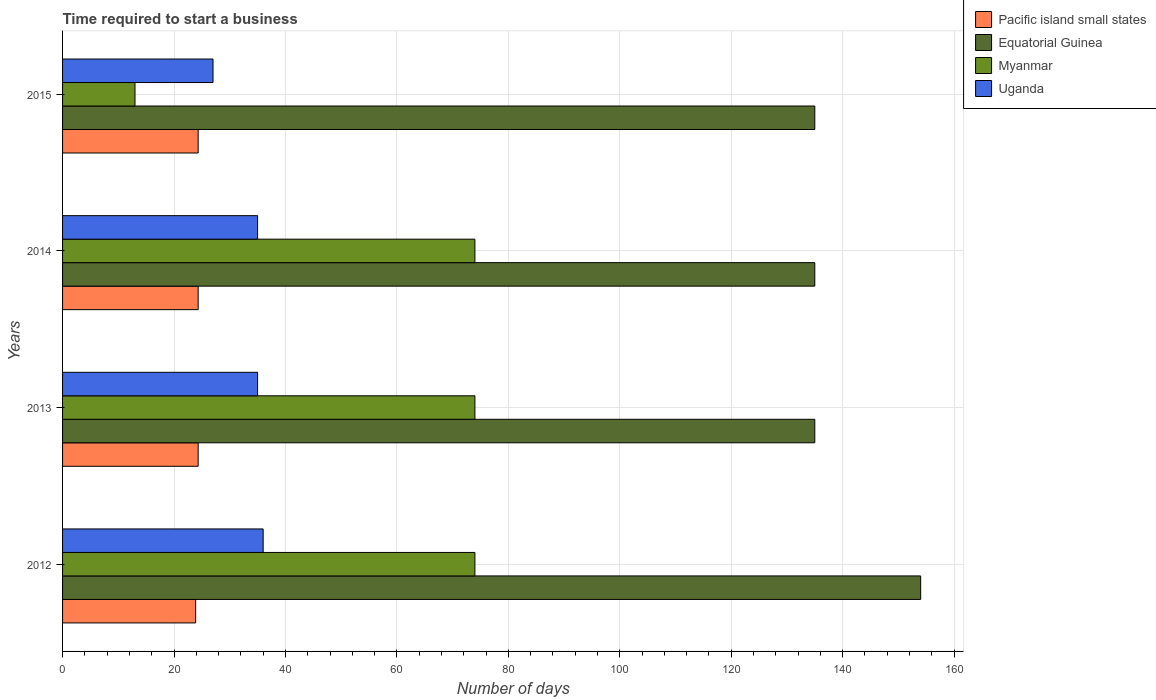In how many cases, is the number of bars for a given year not equal to the number of legend labels?
Your response must be concise. 0. Across all years, what is the maximum number of days required to start a business in Myanmar?
Your response must be concise. 74. Across all years, what is the minimum number of days required to start a business in Uganda?
Your answer should be very brief. 27. In which year was the number of days required to start a business in Equatorial Guinea minimum?
Ensure brevity in your answer.  2013. What is the total number of days required to start a business in Uganda in the graph?
Your answer should be very brief. 133. What is the difference between the number of days required to start a business in Myanmar in 2013 and the number of days required to start a business in Uganda in 2012?
Offer a terse response. 38. What is the average number of days required to start a business in Uganda per year?
Provide a short and direct response. 33.25. In the year 2015, what is the difference between the number of days required to start a business in Myanmar and number of days required to start a business in Pacific island small states?
Ensure brevity in your answer.  -11.33. In how many years, is the number of days required to start a business in Equatorial Guinea greater than 92 days?
Ensure brevity in your answer.  4. What is the ratio of the number of days required to start a business in Uganda in 2012 to that in 2015?
Your answer should be very brief. 1.33. Is the number of days required to start a business in Myanmar in 2013 less than that in 2014?
Your answer should be compact. No. What is the difference between the highest and the second highest number of days required to start a business in Equatorial Guinea?
Offer a very short reply. 19. What is the difference between the highest and the lowest number of days required to start a business in Myanmar?
Keep it short and to the point. 61. What does the 2nd bar from the top in 2013 represents?
Ensure brevity in your answer.  Myanmar. What does the 1st bar from the bottom in 2012 represents?
Your response must be concise. Pacific island small states. Is it the case that in every year, the sum of the number of days required to start a business in Myanmar and number of days required to start a business in Uganda is greater than the number of days required to start a business in Pacific island small states?
Keep it short and to the point. Yes. Are the values on the major ticks of X-axis written in scientific E-notation?
Keep it short and to the point. No. Where does the legend appear in the graph?
Provide a short and direct response. Top right. What is the title of the graph?
Your response must be concise. Time required to start a business. Does "Suriname" appear as one of the legend labels in the graph?
Keep it short and to the point. No. What is the label or title of the X-axis?
Keep it short and to the point. Number of days. What is the label or title of the Y-axis?
Give a very brief answer. Years. What is the Number of days in Pacific island small states in 2012?
Give a very brief answer. 23.89. What is the Number of days in Equatorial Guinea in 2012?
Make the answer very short. 154. What is the Number of days of Myanmar in 2012?
Ensure brevity in your answer.  74. What is the Number of days in Uganda in 2012?
Your response must be concise. 36. What is the Number of days in Pacific island small states in 2013?
Your response must be concise. 24.33. What is the Number of days in Equatorial Guinea in 2013?
Your answer should be compact. 135. What is the Number of days of Uganda in 2013?
Your answer should be very brief. 35. What is the Number of days of Pacific island small states in 2014?
Make the answer very short. 24.33. What is the Number of days of Equatorial Guinea in 2014?
Offer a very short reply. 135. What is the Number of days in Uganda in 2014?
Provide a succinct answer. 35. What is the Number of days in Pacific island small states in 2015?
Your answer should be very brief. 24.33. What is the Number of days of Equatorial Guinea in 2015?
Offer a terse response. 135. What is the Number of days of Myanmar in 2015?
Provide a succinct answer. 13. What is the Number of days of Uganda in 2015?
Make the answer very short. 27. Across all years, what is the maximum Number of days of Pacific island small states?
Your answer should be compact. 24.33. Across all years, what is the maximum Number of days of Equatorial Guinea?
Your answer should be very brief. 154. Across all years, what is the minimum Number of days of Pacific island small states?
Make the answer very short. 23.89. Across all years, what is the minimum Number of days of Equatorial Guinea?
Your response must be concise. 135. Across all years, what is the minimum Number of days of Myanmar?
Offer a terse response. 13. What is the total Number of days in Pacific island small states in the graph?
Your answer should be very brief. 96.89. What is the total Number of days in Equatorial Guinea in the graph?
Your response must be concise. 559. What is the total Number of days in Myanmar in the graph?
Your answer should be compact. 235. What is the total Number of days of Uganda in the graph?
Your response must be concise. 133. What is the difference between the Number of days of Pacific island small states in 2012 and that in 2013?
Your answer should be very brief. -0.44. What is the difference between the Number of days of Myanmar in 2012 and that in 2013?
Your response must be concise. 0. What is the difference between the Number of days of Pacific island small states in 2012 and that in 2014?
Offer a terse response. -0.44. What is the difference between the Number of days of Equatorial Guinea in 2012 and that in 2014?
Your answer should be very brief. 19. What is the difference between the Number of days of Pacific island small states in 2012 and that in 2015?
Offer a very short reply. -0.44. What is the difference between the Number of days in Equatorial Guinea in 2012 and that in 2015?
Keep it short and to the point. 19. What is the difference between the Number of days of Myanmar in 2012 and that in 2015?
Provide a succinct answer. 61. What is the difference between the Number of days of Pacific island small states in 2013 and that in 2014?
Give a very brief answer. 0. What is the difference between the Number of days of Myanmar in 2013 and that in 2014?
Keep it short and to the point. 0. What is the difference between the Number of days in Uganda in 2013 and that in 2014?
Offer a terse response. 0. What is the difference between the Number of days of Pacific island small states in 2013 and that in 2015?
Offer a very short reply. 0. What is the difference between the Number of days in Equatorial Guinea in 2013 and that in 2015?
Give a very brief answer. 0. What is the difference between the Number of days of Myanmar in 2013 and that in 2015?
Your answer should be compact. 61. What is the difference between the Number of days in Pacific island small states in 2014 and that in 2015?
Give a very brief answer. 0. What is the difference between the Number of days in Pacific island small states in 2012 and the Number of days in Equatorial Guinea in 2013?
Your answer should be compact. -111.11. What is the difference between the Number of days in Pacific island small states in 2012 and the Number of days in Myanmar in 2013?
Your response must be concise. -50.11. What is the difference between the Number of days of Pacific island small states in 2012 and the Number of days of Uganda in 2013?
Your answer should be compact. -11.11. What is the difference between the Number of days in Equatorial Guinea in 2012 and the Number of days in Uganda in 2013?
Provide a short and direct response. 119. What is the difference between the Number of days of Myanmar in 2012 and the Number of days of Uganda in 2013?
Make the answer very short. 39. What is the difference between the Number of days in Pacific island small states in 2012 and the Number of days in Equatorial Guinea in 2014?
Ensure brevity in your answer.  -111.11. What is the difference between the Number of days in Pacific island small states in 2012 and the Number of days in Myanmar in 2014?
Offer a terse response. -50.11. What is the difference between the Number of days in Pacific island small states in 2012 and the Number of days in Uganda in 2014?
Keep it short and to the point. -11.11. What is the difference between the Number of days in Equatorial Guinea in 2012 and the Number of days in Myanmar in 2014?
Your answer should be compact. 80. What is the difference between the Number of days of Equatorial Guinea in 2012 and the Number of days of Uganda in 2014?
Your answer should be very brief. 119. What is the difference between the Number of days in Myanmar in 2012 and the Number of days in Uganda in 2014?
Offer a very short reply. 39. What is the difference between the Number of days of Pacific island small states in 2012 and the Number of days of Equatorial Guinea in 2015?
Give a very brief answer. -111.11. What is the difference between the Number of days of Pacific island small states in 2012 and the Number of days of Myanmar in 2015?
Your response must be concise. 10.89. What is the difference between the Number of days of Pacific island small states in 2012 and the Number of days of Uganda in 2015?
Keep it short and to the point. -3.11. What is the difference between the Number of days in Equatorial Guinea in 2012 and the Number of days in Myanmar in 2015?
Offer a terse response. 141. What is the difference between the Number of days in Equatorial Guinea in 2012 and the Number of days in Uganda in 2015?
Keep it short and to the point. 127. What is the difference between the Number of days in Pacific island small states in 2013 and the Number of days in Equatorial Guinea in 2014?
Offer a very short reply. -110.67. What is the difference between the Number of days in Pacific island small states in 2013 and the Number of days in Myanmar in 2014?
Offer a very short reply. -49.67. What is the difference between the Number of days of Pacific island small states in 2013 and the Number of days of Uganda in 2014?
Offer a very short reply. -10.67. What is the difference between the Number of days of Equatorial Guinea in 2013 and the Number of days of Myanmar in 2014?
Your answer should be compact. 61. What is the difference between the Number of days of Myanmar in 2013 and the Number of days of Uganda in 2014?
Provide a succinct answer. 39. What is the difference between the Number of days of Pacific island small states in 2013 and the Number of days of Equatorial Guinea in 2015?
Keep it short and to the point. -110.67. What is the difference between the Number of days in Pacific island small states in 2013 and the Number of days in Myanmar in 2015?
Your answer should be very brief. 11.33. What is the difference between the Number of days of Pacific island small states in 2013 and the Number of days of Uganda in 2015?
Offer a very short reply. -2.67. What is the difference between the Number of days in Equatorial Guinea in 2013 and the Number of days in Myanmar in 2015?
Offer a very short reply. 122. What is the difference between the Number of days of Equatorial Guinea in 2013 and the Number of days of Uganda in 2015?
Offer a terse response. 108. What is the difference between the Number of days in Pacific island small states in 2014 and the Number of days in Equatorial Guinea in 2015?
Your answer should be very brief. -110.67. What is the difference between the Number of days in Pacific island small states in 2014 and the Number of days in Myanmar in 2015?
Give a very brief answer. 11.33. What is the difference between the Number of days in Pacific island small states in 2014 and the Number of days in Uganda in 2015?
Provide a succinct answer. -2.67. What is the difference between the Number of days in Equatorial Guinea in 2014 and the Number of days in Myanmar in 2015?
Ensure brevity in your answer.  122. What is the difference between the Number of days of Equatorial Guinea in 2014 and the Number of days of Uganda in 2015?
Give a very brief answer. 108. What is the difference between the Number of days in Myanmar in 2014 and the Number of days in Uganda in 2015?
Provide a succinct answer. 47. What is the average Number of days of Pacific island small states per year?
Your response must be concise. 24.22. What is the average Number of days in Equatorial Guinea per year?
Ensure brevity in your answer.  139.75. What is the average Number of days of Myanmar per year?
Keep it short and to the point. 58.75. What is the average Number of days of Uganda per year?
Give a very brief answer. 33.25. In the year 2012, what is the difference between the Number of days of Pacific island small states and Number of days of Equatorial Guinea?
Keep it short and to the point. -130.11. In the year 2012, what is the difference between the Number of days in Pacific island small states and Number of days in Myanmar?
Keep it short and to the point. -50.11. In the year 2012, what is the difference between the Number of days in Pacific island small states and Number of days in Uganda?
Provide a succinct answer. -12.11. In the year 2012, what is the difference between the Number of days in Equatorial Guinea and Number of days in Myanmar?
Offer a terse response. 80. In the year 2012, what is the difference between the Number of days of Equatorial Guinea and Number of days of Uganda?
Your answer should be compact. 118. In the year 2012, what is the difference between the Number of days in Myanmar and Number of days in Uganda?
Your response must be concise. 38. In the year 2013, what is the difference between the Number of days of Pacific island small states and Number of days of Equatorial Guinea?
Offer a terse response. -110.67. In the year 2013, what is the difference between the Number of days in Pacific island small states and Number of days in Myanmar?
Your answer should be compact. -49.67. In the year 2013, what is the difference between the Number of days of Pacific island small states and Number of days of Uganda?
Give a very brief answer. -10.67. In the year 2014, what is the difference between the Number of days in Pacific island small states and Number of days in Equatorial Guinea?
Offer a terse response. -110.67. In the year 2014, what is the difference between the Number of days of Pacific island small states and Number of days of Myanmar?
Make the answer very short. -49.67. In the year 2014, what is the difference between the Number of days of Pacific island small states and Number of days of Uganda?
Your answer should be compact. -10.67. In the year 2014, what is the difference between the Number of days of Equatorial Guinea and Number of days of Uganda?
Provide a short and direct response. 100. In the year 2015, what is the difference between the Number of days in Pacific island small states and Number of days in Equatorial Guinea?
Offer a very short reply. -110.67. In the year 2015, what is the difference between the Number of days of Pacific island small states and Number of days of Myanmar?
Provide a short and direct response. 11.33. In the year 2015, what is the difference between the Number of days of Pacific island small states and Number of days of Uganda?
Offer a very short reply. -2.67. In the year 2015, what is the difference between the Number of days in Equatorial Guinea and Number of days in Myanmar?
Your answer should be compact. 122. In the year 2015, what is the difference between the Number of days in Equatorial Guinea and Number of days in Uganda?
Your answer should be compact. 108. What is the ratio of the Number of days of Pacific island small states in 2012 to that in 2013?
Offer a terse response. 0.98. What is the ratio of the Number of days in Equatorial Guinea in 2012 to that in 2013?
Give a very brief answer. 1.14. What is the ratio of the Number of days of Uganda in 2012 to that in 2013?
Ensure brevity in your answer.  1.03. What is the ratio of the Number of days in Pacific island small states in 2012 to that in 2014?
Provide a succinct answer. 0.98. What is the ratio of the Number of days in Equatorial Guinea in 2012 to that in 2014?
Make the answer very short. 1.14. What is the ratio of the Number of days of Myanmar in 2012 to that in 2014?
Your answer should be compact. 1. What is the ratio of the Number of days of Uganda in 2012 to that in 2014?
Give a very brief answer. 1.03. What is the ratio of the Number of days of Pacific island small states in 2012 to that in 2015?
Your answer should be very brief. 0.98. What is the ratio of the Number of days in Equatorial Guinea in 2012 to that in 2015?
Your answer should be very brief. 1.14. What is the ratio of the Number of days of Myanmar in 2012 to that in 2015?
Your answer should be very brief. 5.69. What is the ratio of the Number of days in Equatorial Guinea in 2013 to that in 2014?
Provide a short and direct response. 1. What is the ratio of the Number of days of Uganda in 2013 to that in 2014?
Provide a short and direct response. 1. What is the ratio of the Number of days in Pacific island small states in 2013 to that in 2015?
Keep it short and to the point. 1. What is the ratio of the Number of days in Equatorial Guinea in 2013 to that in 2015?
Offer a very short reply. 1. What is the ratio of the Number of days in Myanmar in 2013 to that in 2015?
Your answer should be very brief. 5.69. What is the ratio of the Number of days in Uganda in 2013 to that in 2015?
Your answer should be compact. 1.3. What is the ratio of the Number of days in Pacific island small states in 2014 to that in 2015?
Ensure brevity in your answer.  1. What is the ratio of the Number of days of Equatorial Guinea in 2014 to that in 2015?
Make the answer very short. 1. What is the ratio of the Number of days of Myanmar in 2014 to that in 2015?
Offer a terse response. 5.69. What is the ratio of the Number of days of Uganda in 2014 to that in 2015?
Provide a short and direct response. 1.3. What is the difference between the highest and the second highest Number of days in Equatorial Guinea?
Make the answer very short. 19. What is the difference between the highest and the second highest Number of days in Myanmar?
Make the answer very short. 0. What is the difference between the highest and the lowest Number of days of Pacific island small states?
Make the answer very short. 0.44. What is the difference between the highest and the lowest Number of days of Equatorial Guinea?
Ensure brevity in your answer.  19. What is the difference between the highest and the lowest Number of days of Uganda?
Offer a terse response. 9. 